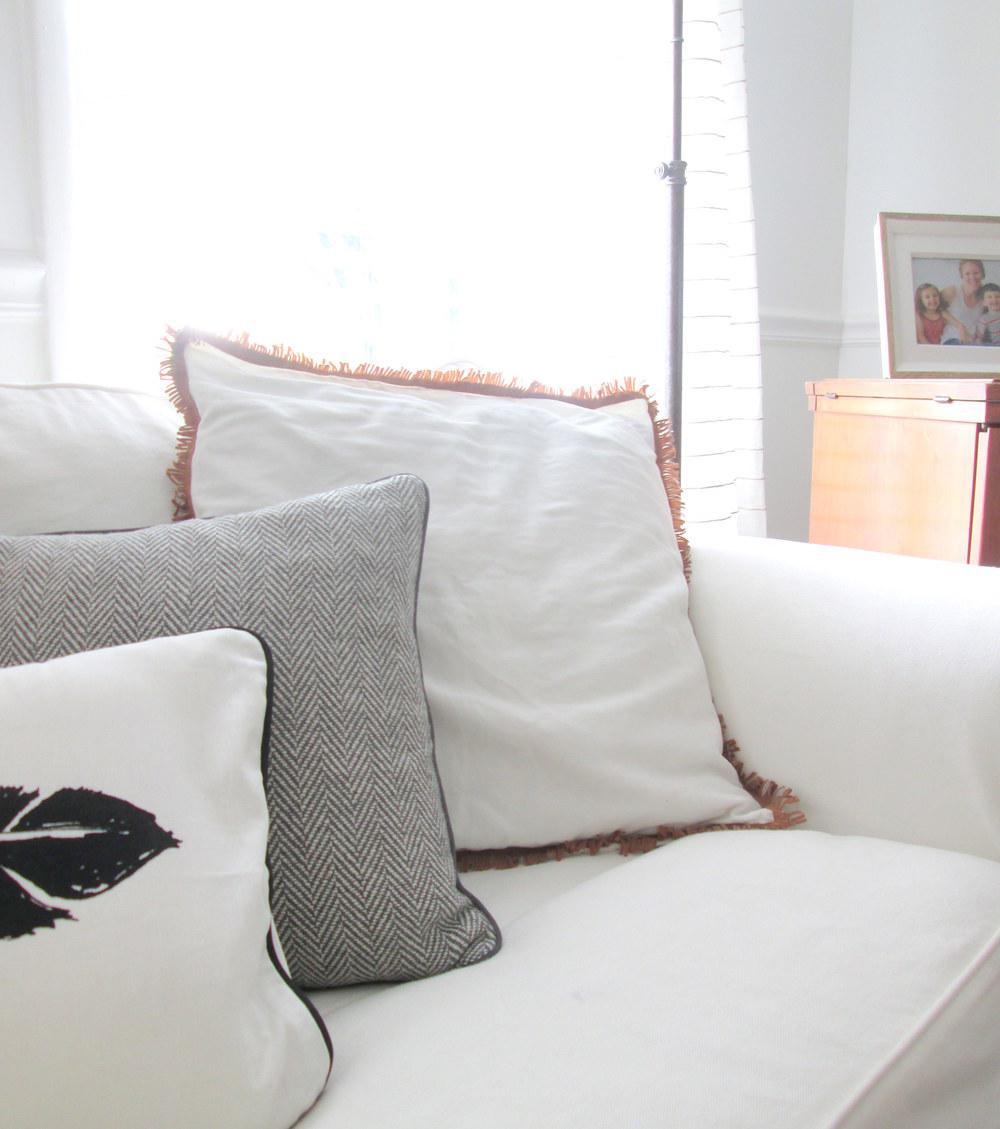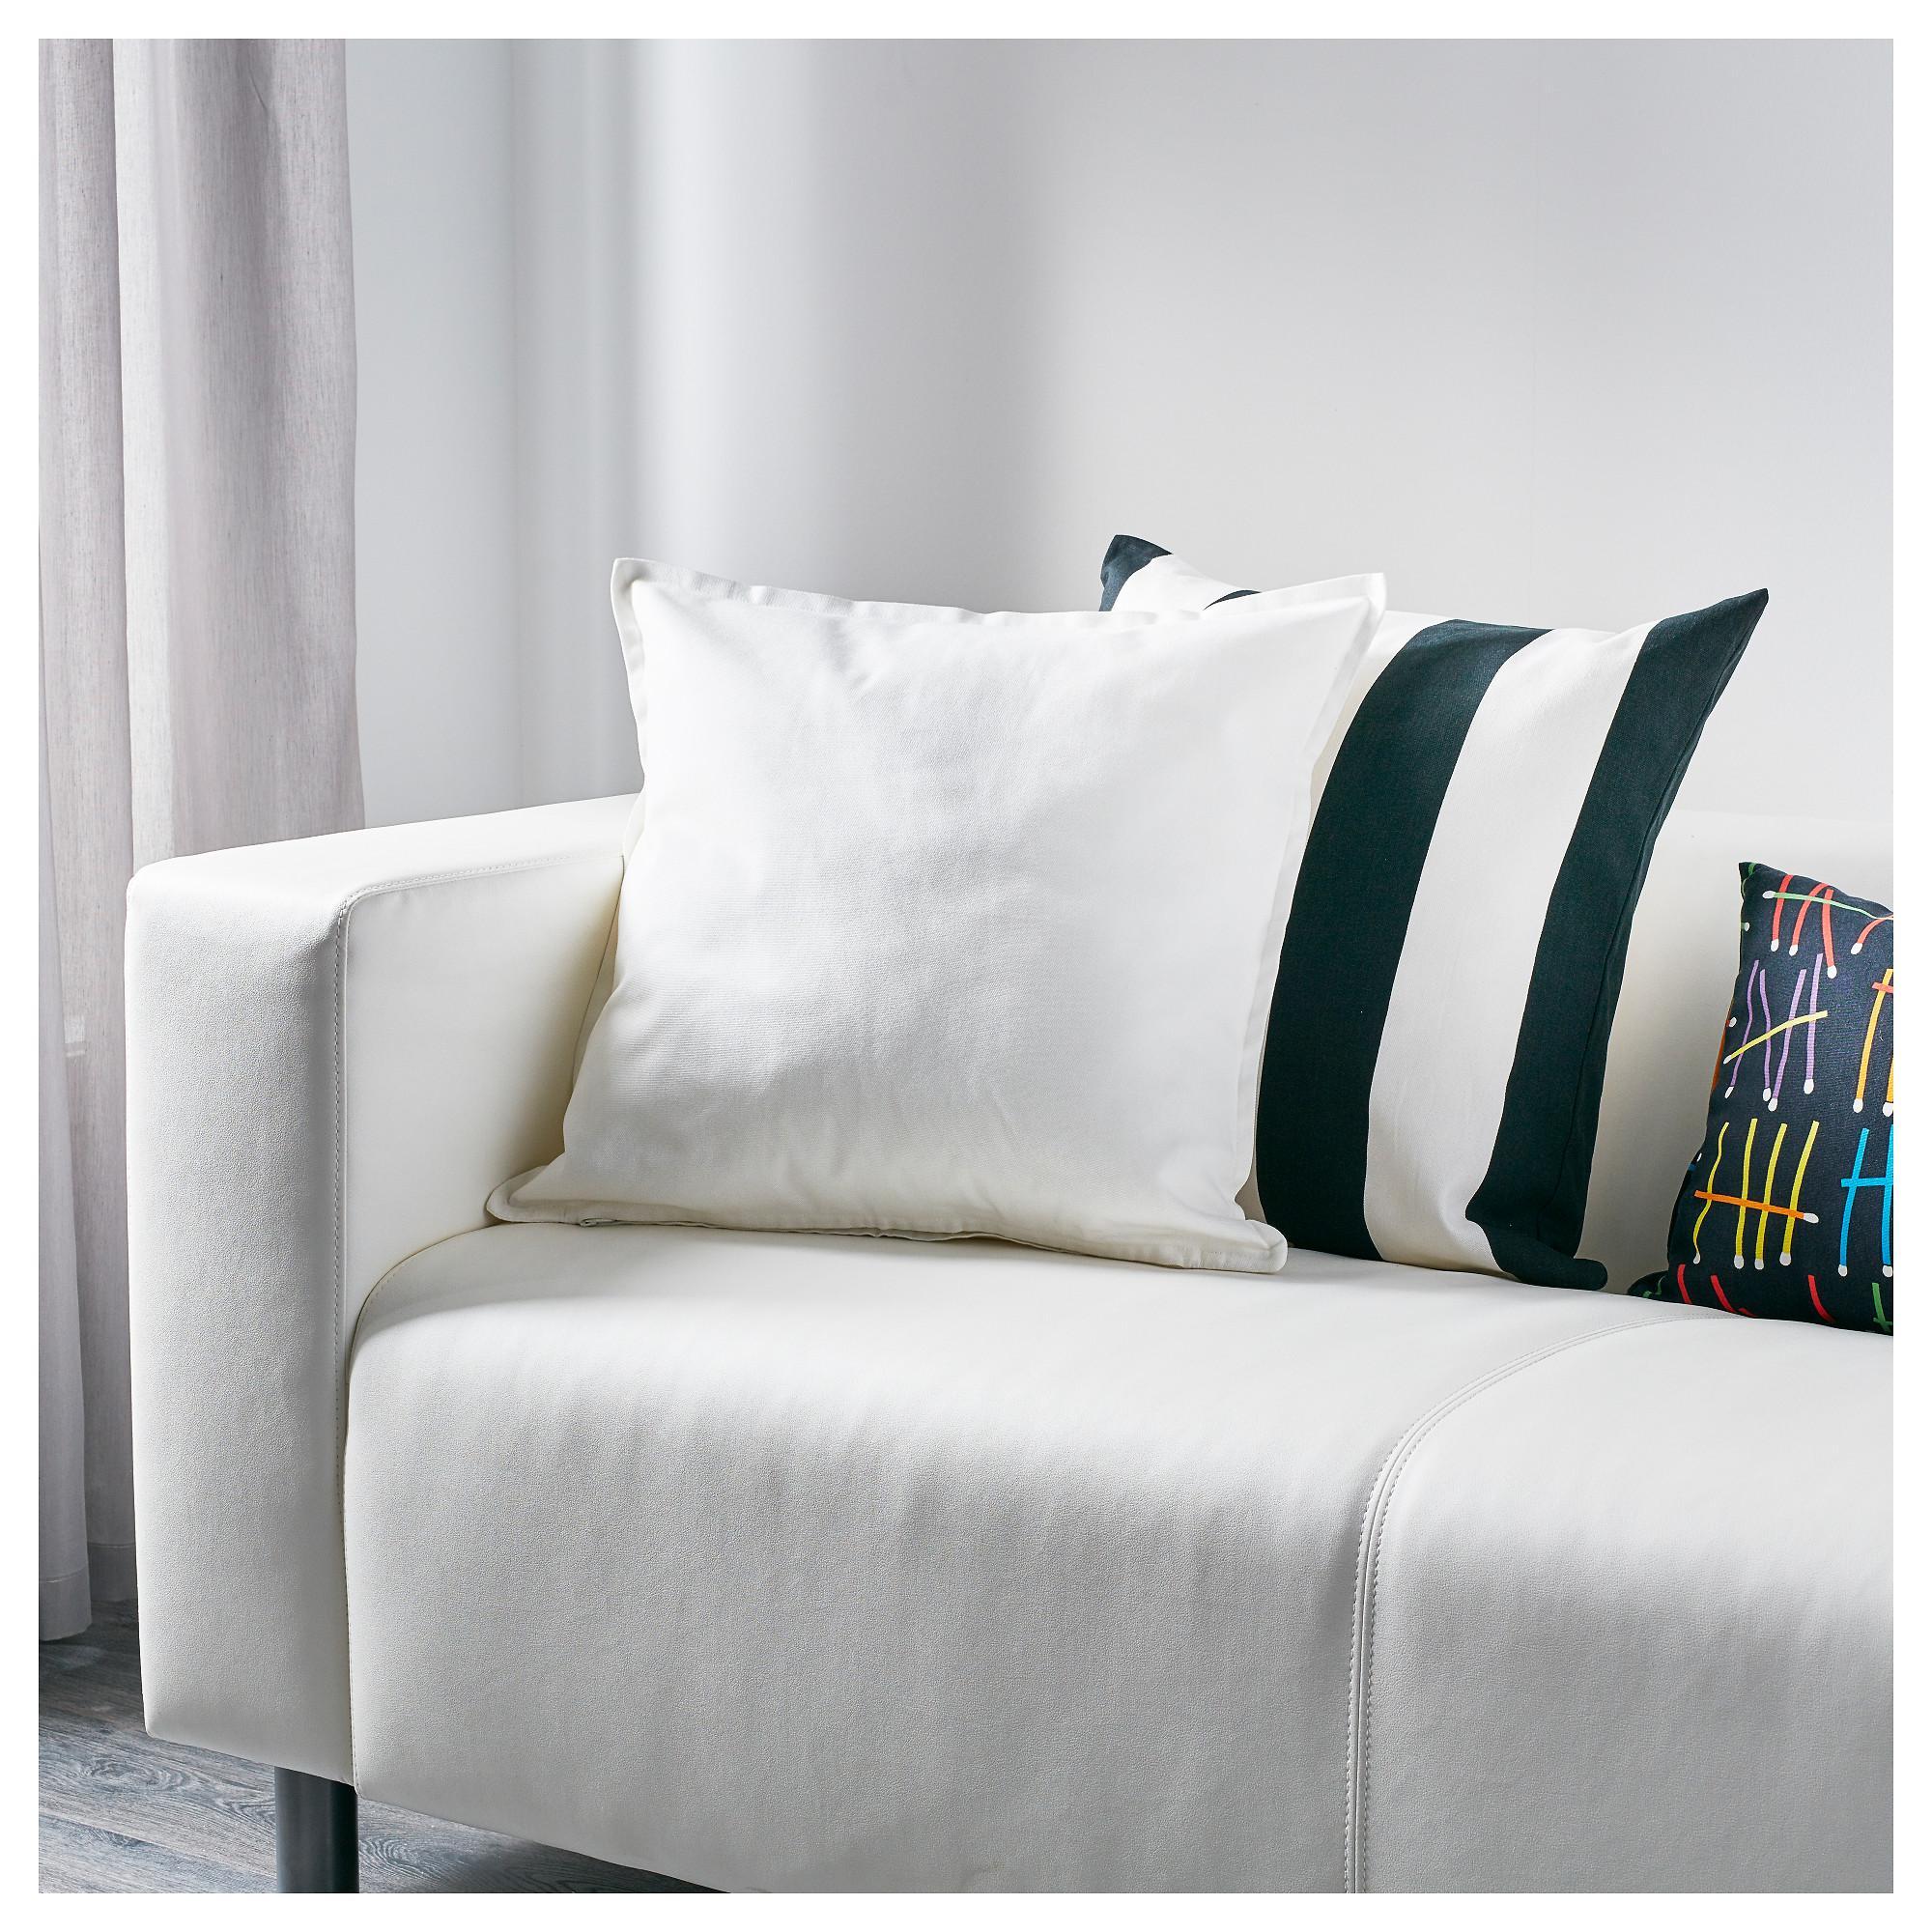The first image is the image on the left, the second image is the image on the right. For the images shown, is this caption "An image shows the corner of a white sofa containing a solid-colored pillow overlapping a striped pillow, and a smaller printed pillow to the right." true? Answer yes or no. Yes. The first image is the image on the left, the second image is the image on the right. Given the left and right images, does the statement "One image shows pillows on a sofa and the other shows a single pillow." hold true? Answer yes or no. No. 